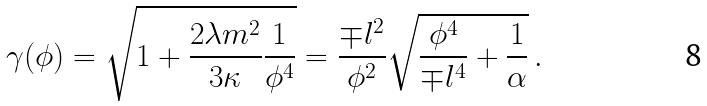<formula> <loc_0><loc_0><loc_500><loc_500>\gamma ( \phi ) = \sqrt { 1 + \frac { 2 \lambda m ^ { 2 } } { 3 \kappa } \frac { 1 } { \phi ^ { 4 } } } = \frac { \mp l ^ { 2 } } { \phi ^ { 2 } } \sqrt { \frac { \phi ^ { 4 } } { \mp l ^ { 4 } } + \frac { 1 } { \alpha } } \, .</formula> 